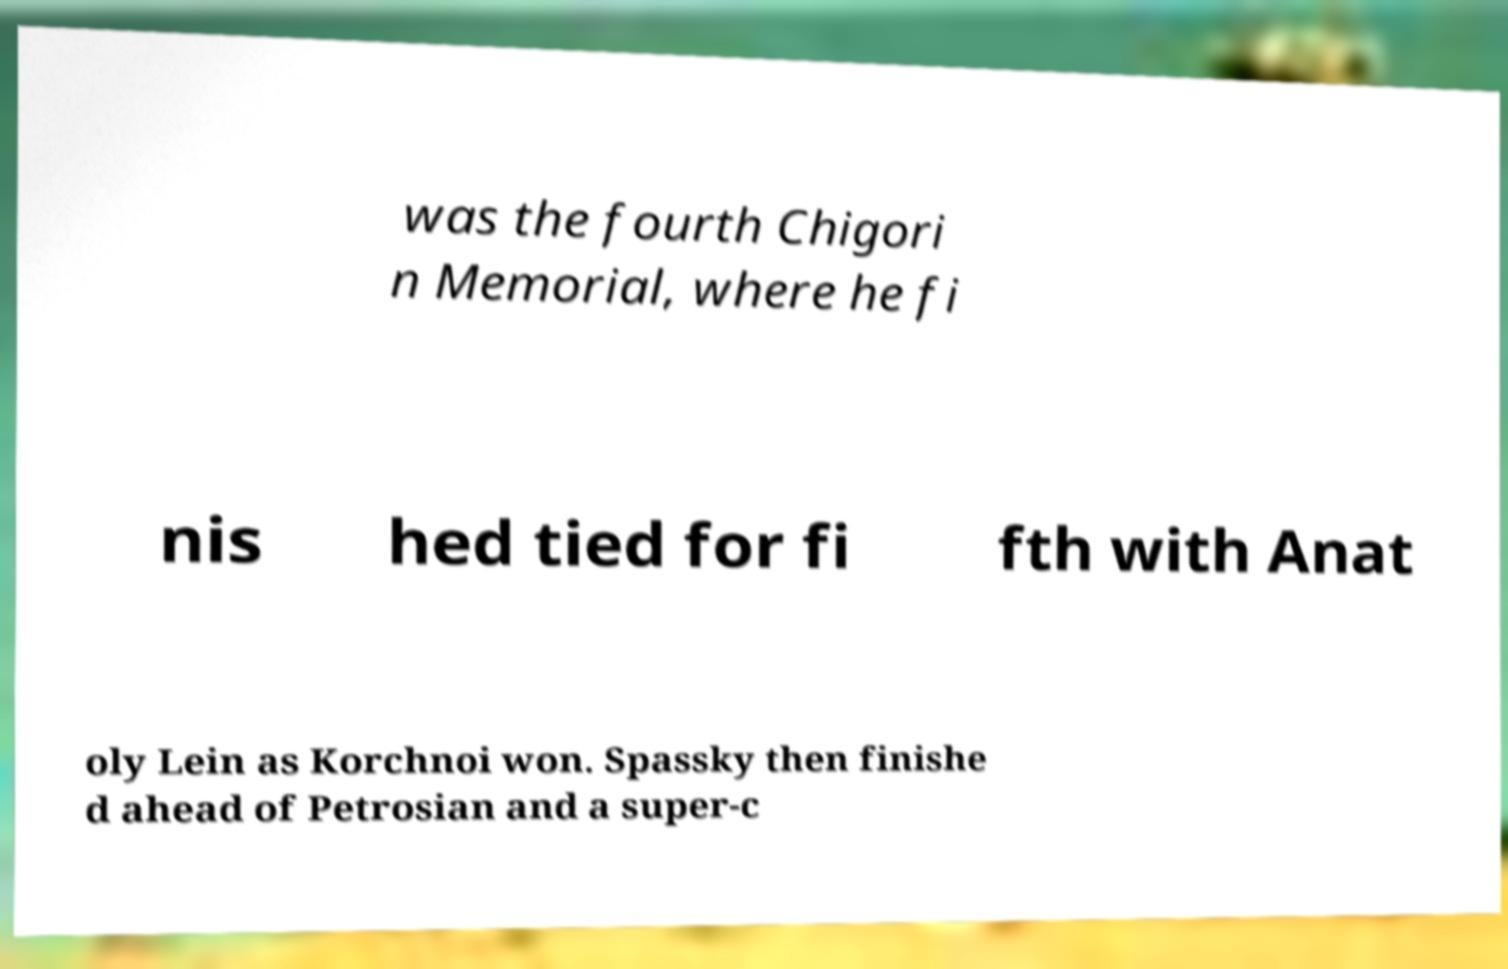For documentation purposes, I need the text within this image transcribed. Could you provide that? was the fourth Chigori n Memorial, where he fi nis hed tied for fi fth with Anat oly Lein as Korchnoi won. Spassky then finishe d ahead of Petrosian and a super-c 